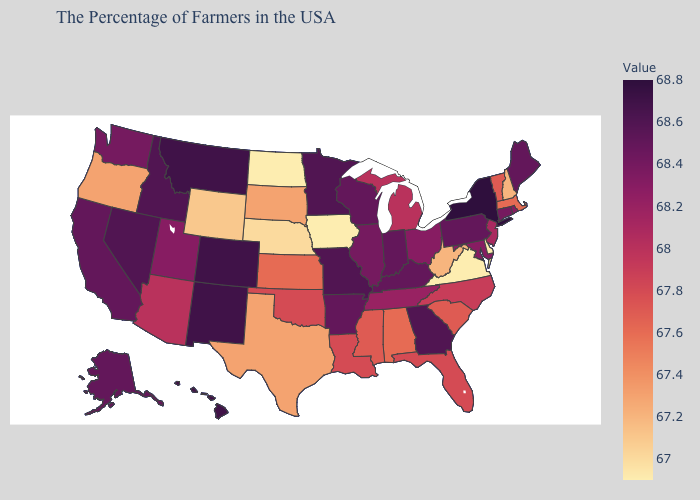Which states have the highest value in the USA?
Give a very brief answer. New York. Does Colorado have the highest value in the West?
Concise answer only. Yes. Does the map have missing data?
Answer briefly. No. Which states have the highest value in the USA?
Answer briefly. New York. Does Vermont have a lower value than Nevada?
Keep it brief. Yes. 